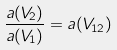Convert formula to latex. <formula><loc_0><loc_0><loc_500><loc_500>\frac { a ( V _ { 2 } ) } { a ( V _ { 1 } ) } = a ( V _ { 1 2 } )</formula> 